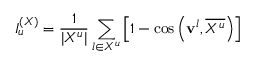<formula> <loc_0><loc_0><loc_500><loc_500>I _ { u } ^ { ( X ) } = \frac { 1 } { | X ^ { u } | } \sum _ { l \in X ^ { u } } \left [ 1 - \cos \left ( { v } ^ { l } , \overline { { X ^ { u } } } \right ) \right ]</formula> 